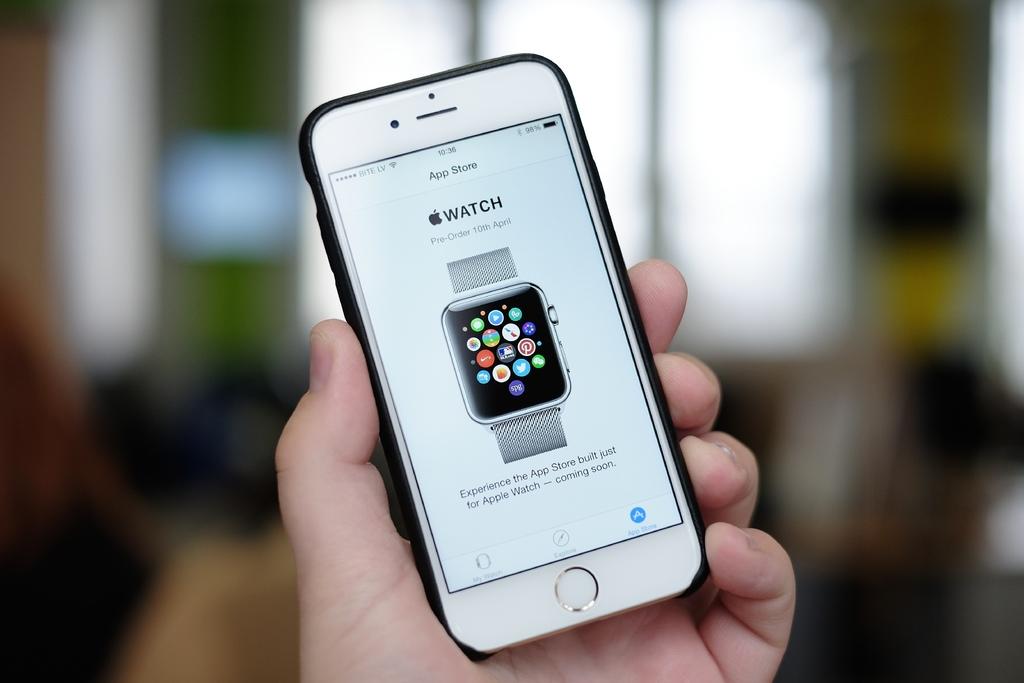Is that an apple watch?
Give a very brief answer. Yes. 